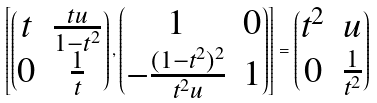Convert formula to latex. <formula><loc_0><loc_0><loc_500><loc_500>\left [ \begin{pmatrix} t & \frac { t u } { 1 - t ^ { 2 } } \\ 0 & \frac { 1 } { t } \end{pmatrix} , \begin{pmatrix} 1 & 0 \\ - \frac { ( 1 - t ^ { 2 } ) ^ { 2 } } { t ^ { 2 } u } & 1 \end{pmatrix} \right ] = \begin{pmatrix} t ^ { 2 } & u \\ 0 & \frac { 1 } { t ^ { 2 } } \end{pmatrix}</formula> 